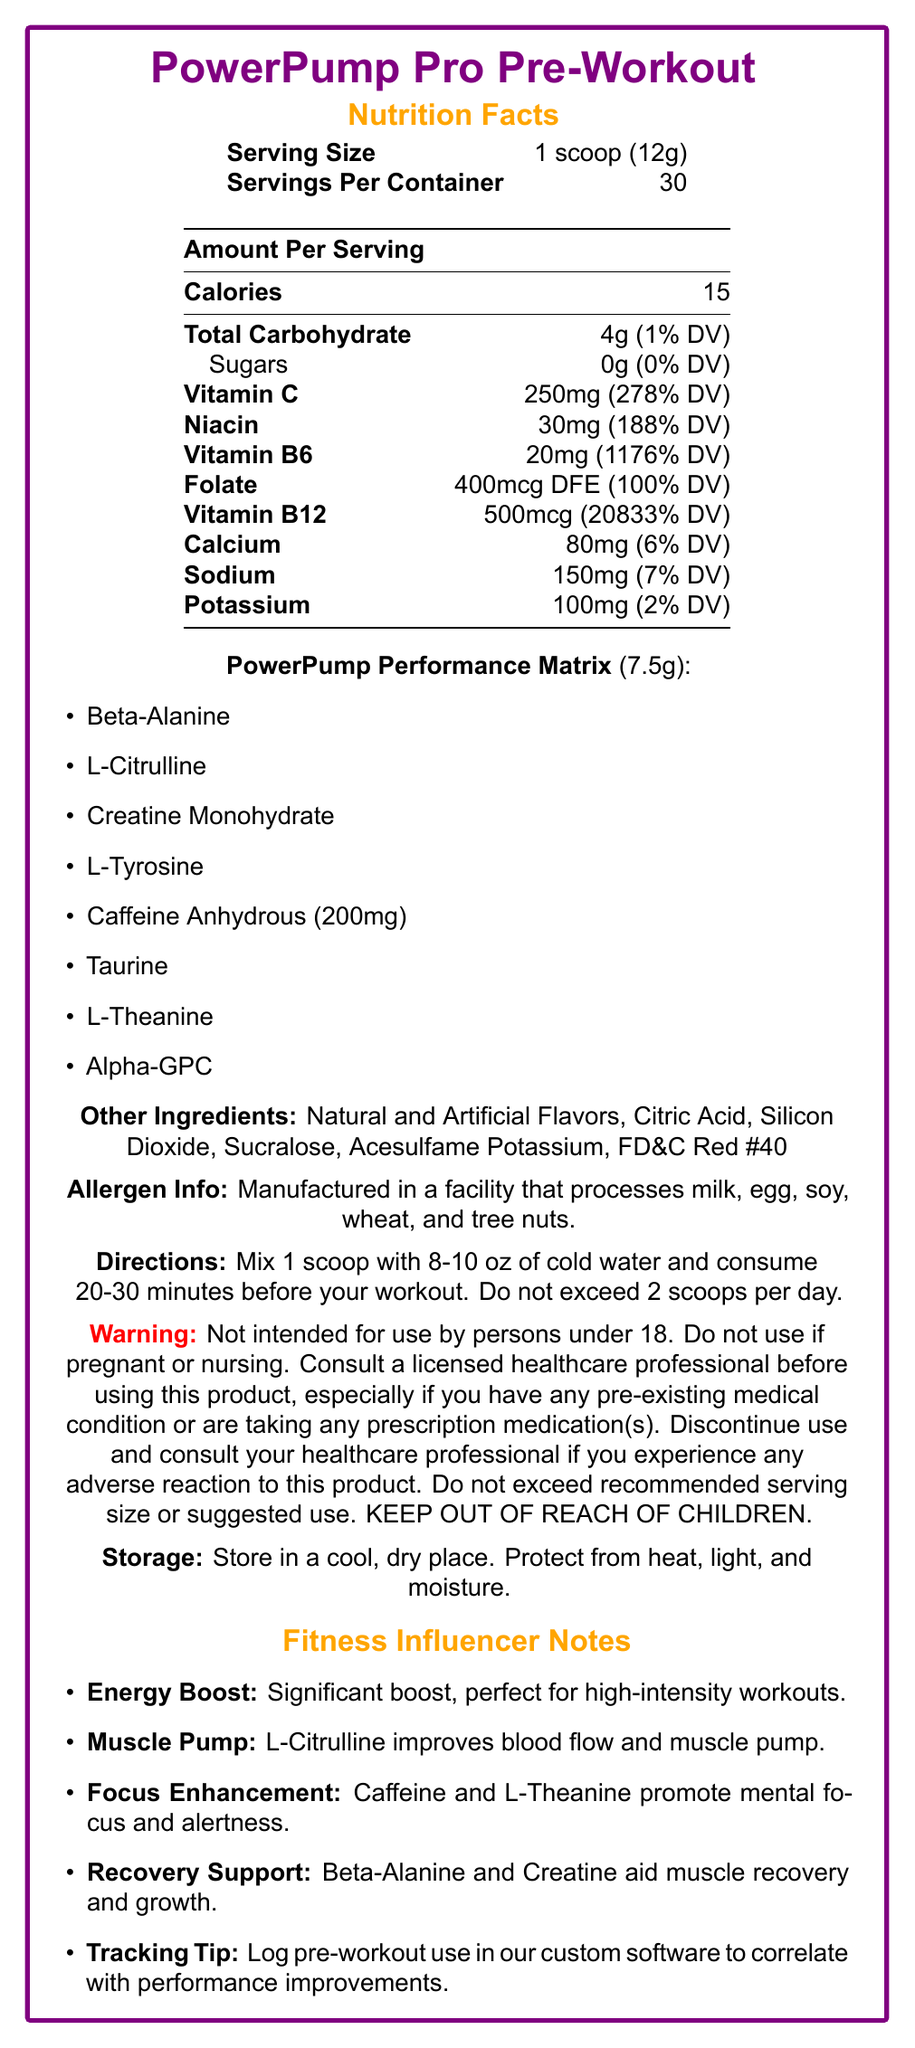What is the serving size of PowerPump Pro Pre-Workout? The document states that the serving size is 1 scoop, which weighs 12 grams.
Answer: 1 scoop (12g) How many servings are there per container of PowerPump Pro Pre-Workout? The document specifies that there are 30 servings per container.
Answer: 30 How much Vitamin C does one serving contain? According to the document, one serving contains 250mg of Vitamin C.
Answer: 250mg What is the daily value percentage of Vitamin B12 per serving? The document mentions that one serving of the supplement provides 20833% of the daily value for Vitamin B12.
Answer: 20833% Which ingredient in the PowerPump Performance Matrix is responsible for providing an energy boost? The fitness influencer notes mention Caffeine Anhydrous as a key ingredient for providing an energy boost.
Answer: Caffeine Anhydrous (200mg) How much calcium is in one serving? The document states that one serving contains 80mg of calcium.
Answer: 80mg What is the main benefit of L-Citrulline mentioned in the document? The fitness influencer notes that L-Citrulline helps improve blood flow and muscle pump during training.
Answer: Improves blood flow and muscle pump What is the recommended water volume to mix with one scoop of the supplement? The directions in the document suggest mixing 1 scoop with 8-10 oz of cold water.
Answer: 8-10 oz What is the total carbohydrate content in one serving? The document lists the total carbohydrate content as 4g per serving.
Answer: 4g Which of the following vitamins has the highest daily value percentage per serving in the supplement? 
A. Vitamin C
B. Niacin
C. Vitamin B6
D. Vitamin B12 The daily value percentage for Vitamin B12 per serving is 20833%, which is the highest among the listed vitamins.
Answer: D. Vitamin B12 Which of the following ingredients is NOT part of the PowerPump Performance Matrix?
1. Beta-Alanine
2. Sodium
3. L-Citrulline
4. L-Tyrosine Sodium is listed under the "Amount Per Serving" section and not as part of the PowerPump Performance Matrix.
Answer: 2. Sodium Is this product suitable for individuals under 18 years old? The warning clearly states that the product is not intended for use by persons under 18.
Answer: No What are the storage instructions for PowerPump Pro Pre-Workout? The storage section of the document provides these instructions.
Answer: Store in a cool, dry place. Protect from heat, light, and moisture. What is a suggested use for tracking the effectiveness of this pre-workout supplement? The fitness influencer notes suggest logging pre-workout use in the custom software for tracking effectiveness.
Answer: Log pre-workout use in the custom workout tracking software to correlate with performance improvements. Can the exact ingredients of the proprietary blend be determined from the document? The document lists the ingredients in the PowerPump Performance Matrix, which is the proprietary blend.
Answer: Yes How many grams of sugar are in one serving? The document states that there are 0g of sugars per serving.
Answer: 0g What are potential allergens mentioned for this product? The allergen information states that the product is manufactured in a facility that processes these allergens.
Answer: Milk, egg, soy, wheat, and tree nuts Provide a summary of the document. The summary encapsulates the primary content and key areas covered in the document such as nutritional information, proprietary ingredients, usage, warnings, and storage instructions.
Answer: The document is a detailed Nutrition Facts Label for "PowerPump Pro Pre-Workout". It includes serving size and servings per container, lists the nutritional content (calories, carbohydrates, various vitamins, and minerals), and breaks down the proprietary blend of performance-enhancing ingredients. Additionally, it covers the directions for use, warning about its use for specific populations, storage instructions, potential allergens, and fitness influencer notes about its benefits. What is the exact contribution of creatine monohydrate to muscle recovery? The document mentions that Beta-Alanine and Creatine aid in muscle recovery and growth, but it does not specify the exact contribution of creatine monohydrate.
Answer: Cannot be determined 